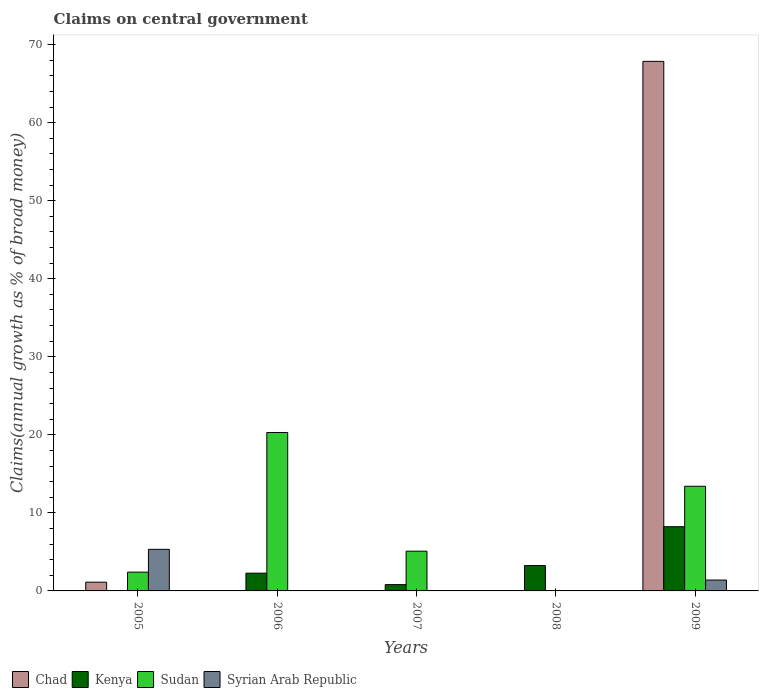Are the number of bars on each tick of the X-axis equal?
Make the answer very short. No. How many bars are there on the 4th tick from the left?
Your answer should be very brief. 1. How many bars are there on the 3rd tick from the right?
Offer a very short reply. 2. What is the label of the 4th group of bars from the left?
Offer a very short reply. 2008. What is the percentage of broad money claimed on centeral government in Chad in 2005?
Make the answer very short. 1.12. Across all years, what is the maximum percentage of broad money claimed on centeral government in Chad?
Your response must be concise. 67.86. What is the total percentage of broad money claimed on centeral government in Kenya in the graph?
Your answer should be compact. 14.55. What is the difference between the percentage of broad money claimed on centeral government in Sudan in 2006 and that in 2009?
Give a very brief answer. 6.89. What is the average percentage of broad money claimed on centeral government in Syrian Arab Republic per year?
Provide a short and direct response. 1.34. In the year 2009, what is the difference between the percentage of broad money claimed on centeral government in Sudan and percentage of broad money claimed on centeral government in Chad?
Give a very brief answer. -54.45. In how many years, is the percentage of broad money claimed on centeral government in Syrian Arab Republic greater than 24 %?
Offer a very short reply. 0. Is the difference between the percentage of broad money claimed on centeral government in Sudan in 2005 and 2009 greater than the difference between the percentage of broad money claimed on centeral government in Chad in 2005 and 2009?
Make the answer very short. Yes. What is the difference between the highest and the second highest percentage of broad money claimed on centeral government in Sudan?
Your answer should be very brief. 6.89. What is the difference between the highest and the lowest percentage of broad money claimed on centeral government in Chad?
Offer a terse response. 67.86. In how many years, is the percentage of broad money claimed on centeral government in Syrian Arab Republic greater than the average percentage of broad money claimed on centeral government in Syrian Arab Republic taken over all years?
Your answer should be very brief. 2. How many bars are there?
Provide a succinct answer. 12. Are all the bars in the graph horizontal?
Provide a short and direct response. No. Are the values on the major ticks of Y-axis written in scientific E-notation?
Your answer should be compact. No. Does the graph contain grids?
Your answer should be very brief. No. How many legend labels are there?
Offer a terse response. 4. How are the legend labels stacked?
Make the answer very short. Horizontal. What is the title of the graph?
Your answer should be very brief. Claims on central government. What is the label or title of the X-axis?
Your answer should be very brief. Years. What is the label or title of the Y-axis?
Provide a succinct answer. Claims(annual growth as % of broad money). What is the Claims(annual growth as % of broad money) of Chad in 2005?
Your answer should be very brief. 1.12. What is the Claims(annual growth as % of broad money) of Sudan in 2005?
Provide a succinct answer. 2.41. What is the Claims(annual growth as % of broad money) of Syrian Arab Republic in 2005?
Your response must be concise. 5.33. What is the Claims(annual growth as % of broad money) in Kenya in 2006?
Your response must be concise. 2.27. What is the Claims(annual growth as % of broad money) in Sudan in 2006?
Offer a very short reply. 20.3. What is the Claims(annual growth as % of broad money) in Chad in 2007?
Provide a short and direct response. 0. What is the Claims(annual growth as % of broad money) of Kenya in 2007?
Your answer should be compact. 0.81. What is the Claims(annual growth as % of broad money) in Sudan in 2007?
Your answer should be very brief. 5.09. What is the Claims(annual growth as % of broad money) of Syrian Arab Republic in 2007?
Your answer should be very brief. 0. What is the Claims(annual growth as % of broad money) of Kenya in 2008?
Provide a succinct answer. 3.24. What is the Claims(annual growth as % of broad money) of Chad in 2009?
Provide a short and direct response. 67.86. What is the Claims(annual growth as % of broad money) in Kenya in 2009?
Give a very brief answer. 8.23. What is the Claims(annual growth as % of broad money) of Sudan in 2009?
Your answer should be very brief. 13.41. What is the Claims(annual growth as % of broad money) of Syrian Arab Republic in 2009?
Make the answer very short. 1.39. Across all years, what is the maximum Claims(annual growth as % of broad money) in Chad?
Offer a terse response. 67.86. Across all years, what is the maximum Claims(annual growth as % of broad money) of Kenya?
Ensure brevity in your answer.  8.23. Across all years, what is the maximum Claims(annual growth as % of broad money) in Sudan?
Keep it short and to the point. 20.3. Across all years, what is the maximum Claims(annual growth as % of broad money) in Syrian Arab Republic?
Provide a short and direct response. 5.33. Across all years, what is the minimum Claims(annual growth as % of broad money) of Kenya?
Your response must be concise. 0. What is the total Claims(annual growth as % of broad money) of Chad in the graph?
Make the answer very short. 68.98. What is the total Claims(annual growth as % of broad money) of Kenya in the graph?
Your response must be concise. 14.55. What is the total Claims(annual growth as % of broad money) in Sudan in the graph?
Your answer should be compact. 41.21. What is the total Claims(annual growth as % of broad money) in Syrian Arab Republic in the graph?
Make the answer very short. 6.72. What is the difference between the Claims(annual growth as % of broad money) in Sudan in 2005 and that in 2006?
Give a very brief answer. -17.89. What is the difference between the Claims(annual growth as % of broad money) in Sudan in 2005 and that in 2007?
Ensure brevity in your answer.  -2.68. What is the difference between the Claims(annual growth as % of broad money) of Chad in 2005 and that in 2009?
Make the answer very short. -66.73. What is the difference between the Claims(annual growth as % of broad money) in Sudan in 2005 and that in 2009?
Provide a short and direct response. -11. What is the difference between the Claims(annual growth as % of broad money) of Syrian Arab Republic in 2005 and that in 2009?
Ensure brevity in your answer.  3.94. What is the difference between the Claims(annual growth as % of broad money) in Kenya in 2006 and that in 2007?
Your answer should be very brief. 1.47. What is the difference between the Claims(annual growth as % of broad money) in Sudan in 2006 and that in 2007?
Your answer should be compact. 15.21. What is the difference between the Claims(annual growth as % of broad money) in Kenya in 2006 and that in 2008?
Provide a succinct answer. -0.97. What is the difference between the Claims(annual growth as % of broad money) in Kenya in 2006 and that in 2009?
Keep it short and to the point. -5.95. What is the difference between the Claims(annual growth as % of broad money) of Sudan in 2006 and that in 2009?
Your answer should be compact. 6.89. What is the difference between the Claims(annual growth as % of broad money) in Kenya in 2007 and that in 2008?
Offer a very short reply. -2.44. What is the difference between the Claims(annual growth as % of broad money) in Kenya in 2007 and that in 2009?
Keep it short and to the point. -7.42. What is the difference between the Claims(annual growth as % of broad money) in Sudan in 2007 and that in 2009?
Give a very brief answer. -8.32. What is the difference between the Claims(annual growth as % of broad money) in Kenya in 2008 and that in 2009?
Your response must be concise. -4.98. What is the difference between the Claims(annual growth as % of broad money) in Chad in 2005 and the Claims(annual growth as % of broad money) in Kenya in 2006?
Ensure brevity in your answer.  -1.15. What is the difference between the Claims(annual growth as % of broad money) of Chad in 2005 and the Claims(annual growth as % of broad money) of Sudan in 2006?
Provide a short and direct response. -19.18. What is the difference between the Claims(annual growth as % of broad money) of Chad in 2005 and the Claims(annual growth as % of broad money) of Kenya in 2007?
Make the answer very short. 0.32. What is the difference between the Claims(annual growth as % of broad money) in Chad in 2005 and the Claims(annual growth as % of broad money) in Sudan in 2007?
Your answer should be very brief. -3.97. What is the difference between the Claims(annual growth as % of broad money) of Chad in 2005 and the Claims(annual growth as % of broad money) of Kenya in 2008?
Make the answer very short. -2.12. What is the difference between the Claims(annual growth as % of broad money) in Chad in 2005 and the Claims(annual growth as % of broad money) in Kenya in 2009?
Ensure brevity in your answer.  -7.11. What is the difference between the Claims(annual growth as % of broad money) in Chad in 2005 and the Claims(annual growth as % of broad money) in Sudan in 2009?
Make the answer very short. -12.29. What is the difference between the Claims(annual growth as % of broad money) in Chad in 2005 and the Claims(annual growth as % of broad money) in Syrian Arab Republic in 2009?
Provide a succinct answer. -0.27. What is the difference between the Claims(annual growth as % of broad money) in Sudan in 2005 and the Claims(annual growth as % of broad money) in Syrian Arab Republic in 2009?
Provide a succinct answer. 1.01. What is the difference between the Claims(annual growth as % of broad money) in Kenya in 2006 and the Claims(annual growth as % of broad money) in Sudan in 2007?
Provide a short and direct response. -2.82. What is the difference between the Claims(annual growth as % of broad money) in Kenya in 2006 and the Claims(annual growth as % of broad money) in Sudan in 2009?
Give a very brief answer. -11.14. What is the difference between the Claims(annual growth as % of broad money) of Kenya in 2006 and the Claims(annual growth as % of broad money) of Syrian Arab Republic in 2009?
Ensure brevity in your answer.  0.88. What is the difference between the Claims(annual growth as % of broad money) of Sudan in 2006 and the Claims(annual growth as % of broad money) of Syrian Arab Republic in 2009?
Your answer should be compact. 18.91. What is the difference between the Claims(annual growth as % of broad money) of Kenya in 2007 and the Claims(annual growth as % of broad money) of Sudan in 2009?
Ensure brevity in your answer.  -12.6. What is the difference between the Claims(annual growth as % of broad money) in Kenya in 2007 and the Claims(annual growth as % of broad money) in Syrian Arab Republic in 2009?
Provide a short and direct response. -0.59. What is the difference between the Claims(annual growth as % of broad money) in Sudan in 2007 and the Claims(annual growth as % of broad money) in Syrian Arab Republic in 2009?
Your answer should be very brief. 3.7. What is the difference between the Claims(annual growth as % of broad money) in Kenya in 2008 and the Claims(annual growth as % of broad money) in Sudan in 2009?
Your answer should be very brief. -10.17. What is the difference between the Claims(annual growth as % of broad money) in Kenya in 2008 and the Claims(annual growth as % of broad money) in Syrian Arab Republic in 2009?
Give a very brief answer. 1.85. What is the average Claims(annual growth as % of broad money) of Chad per year?
Provide a short and direct response. 13.8. What is the average Claims(annual growth as % of broad money) in Kenya per year?
Offer a very short reply. 2.91. What is the average Claims(annual growth as % of broad money) in Sudan per year?
Provide a short and direct response. 8.24. What is the average Claims(annual growth as % of broad money) in Syrian Arab Republic per year?
Your response must be concise. 1.34. In the year 2005, what is the difference between the Claims(annual growth as % of broad money) of Chad and Claims(annual growth as % of broad money) of Sudan?
Keep it short and to the point. -1.29. In the year 2005, what is the difference between the Claims(annual growth as % of broad money) of Chad and Claims(annual growth as % of broad money) of Syrian Arab Republic?
Keep it short and to the point. -4.21. In the year 2005, what is the difference between the Claims(annual growth as % of broad money) in Sudan and Claims(annual growth as % of broad money) in Syrian Arab Republic?
Your response must be concise. -2.92. In the year 2006, what is the difference between the Claims(annual growth as % of broad money) in Kenya and Claims(annual growth as % of broad money) in Sudan?
Your answer should be very brief. -18.03. In the year 2007, what is the difference between the Claims(annual growth as % of broad money) in Kenya and Claims(annual growth as % of broad money) in Sudan?
Your answer should be compact. -4.28. In the year 2009, what is the difference between the Claims(annual growth as % of broad money) in Chad and Claims(annual growth as % of broad money) in Kenya?
Your answer should be very brief. 59.63. In the year 2009, what is the difference between the Claims(annual growth as % of broad money) of Chad and Claims(annual growth as % of broad money) of Sudan?
Give a very brief answer. 54.45. In the year 2009, what is the difference between the Claims(annual growth as % of broad money) in Chad and Claims(annual growth as % of broad money) in Syrian Arab Republic?
Offer a very short reply. 66.46. In the year 2009, what is the difference between the Claims(annual growth as % of broad money) of Kenya and Claims(annual growth as % of broad money) of Sudan?
Offer a terse response. -5.18. In the year 2009, what is the difference between the Claims(annual growth as % of broad money) in Kenya and Claims(annual growth as % of broad money) in Syrian Arab Republic?
Give a very brief answer. 6.83. In the year 2009, what is the difference between the Claims(annual growth as % of broad money) in Sudan and Claims(annual growth as % of broad money) in Syrian Arab Republic?
Offer a terse response. 12.02. What is the ratio of the Claims(annual growth as % of broad money) in Sudan in 2005 to that in 2006?
Keep it short and to the point. 0.12. What is the ratio of the Claims(annual growth as % of broad money) of Sudan in 2005 to that in 2007?
Keep it short and to the point. 0.47. What is the ratio of the Claims(annual growth as % of broad money) in Chad in 2005 to that in 2009?
Provide a succinct answer. 0.02. What is the ratio of the Claims(annual growth as % of broad money) in Sudan in 2005 to that in 2009?
Ensure brevity in your answer.  0.18. What is the ratio of the Claims(annual growth as % of broad money) of Syrian Arab Republic in 2005 to that in 2009?
Ensure brevity in your answer.  3.83. What is the ratio of the Claims(annual growth as % of broad money) of Kenya in 2006 to that in 2007?
Provide a succinct answer. 2.82. What is the ratio of the Claims(annual growth as % of broad money) of Sudan in 2006 to that in 2007?
Provide a short and direct response. 3.99. What is the ratio of the Claims(annual growth as % of broad money) of Kenya in 2006 to that in 2008?
Provide a succinct answer. 0.7. What is the ratio of the Claims(annual growth as % of broad money) in Kenya in 2006 to that in 2009?
Ensure brevity in your answer.  0.28. What is the ratio of the Claims(annual growth as % of broad money) in Sudan in 2006 to that in 2009?
Your answer should be compact. 1.51. What is the ratio of the Claims(annual growth as % of broad money) of Kenya in 2007 to that in 2008?
Your response must be concise. 0.25. What is the ratio of the Claims(annual growth as % of broad money) of Kenya in 2007 to that in 2009?
Your response must be concise. 0.1. What is the ratio of the Claims(annual growth as % of broad money) in Sudan in 2007 to that in 2009?
Provide a short and direct response. 0.38. What is the ratio of the Claims(annual growth as % of broad money) in Kenya in 2008 to that in 2009?
Ensure brevity in your answer.  0.39. What is the difference between the highest and the second highest Claims(annual growth as % of broad money) of Kenya?
Provide a succinct answer. 4.98. What is the difference between the highest and the second highest Claims(annual growth as % of broad money) of Sudan?
Provide a succinct answer. 6.89. What is the difference between the highest and the lowest Claims(annual growth as % of broad money) in Chad?
Offer a very short reply. 67.86. What is the difference between the highest and the lowest Claims(annual growth as % of broad money) in Kenya?
Ensure brevity in your answer.  8.23. What is the difference between the highest and the lowest Claims(annual growth as % of broad money) in Sudan?
Ensure brevity in your answer.  20.3. What is the difference between the highest and the lowest Claims(annual growth as % of broad money) of Syrian Arab Republic?
Offer a very short reply. 5.33. 